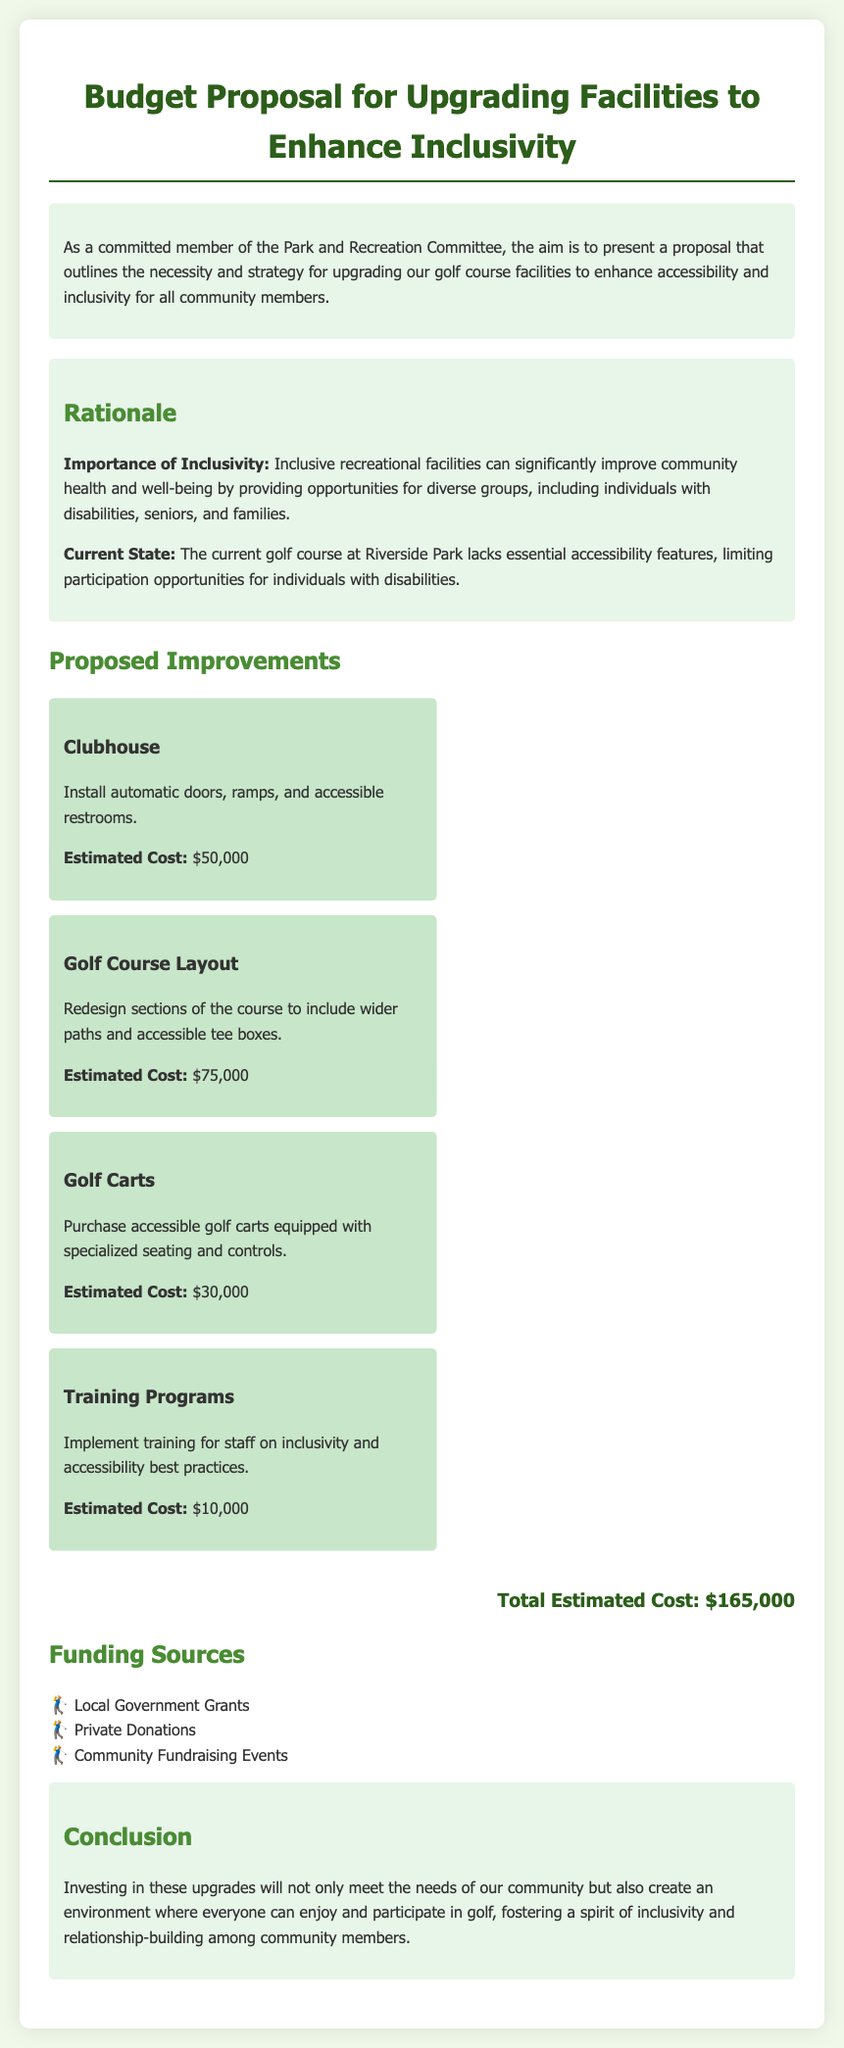What is the title of the proposal? The title is stated at the top of the document, clearly identifying the focus of the proposal.
Answer: Budget Proposal for Upgrading Facilities to Enhance Inclusivity What is the estimated cost for the golf course layout improvement? The document lists the estimated costs for each proposed improvement, including the golf course layout.
Answer: $75,000 What is one funding source mentioned? The document provides a list of potential funding sources for the project.
Answer: Local Government Grants How many proposed improvements are listed? The number of proposed improvements is explicitly mentioned in the section describing them.
Answer: 4 What is the total estimated cost for all proposed improvements? The total cost is summarized at the end of the proposal, combining all individual costs.
Answer: $165,000 Which area of the course will have wider paths? The document specifies which improvements are intended for certain areas, highlighting inclusivity measures.
Answer: Golf Course Layout What type of training is included in the proposed improvements? The document identifies the specific focus of the training program mentioned as part of the upgrades.
Answer: Inclusivity and accessibility best practices What is the importance of inclusivity mentioned in the rationale? The rationale section discusses the community health and social benefits of having inclusivity in recreational facilities.
Answer: Improve community health and well-being 